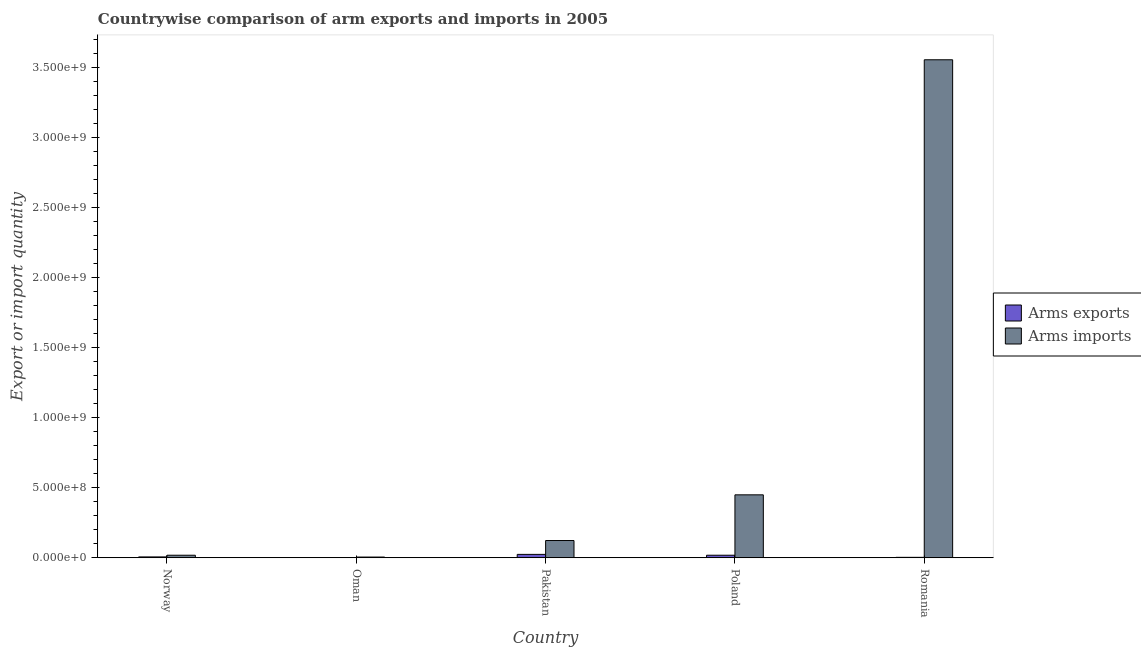How many bars are there on the 2nd tick from the left?
Your answer should be compact. 2. How many bars are there on the 2nd tick from the right?
Keep it short and to the point. 2. In how many cases, is the number of bars for a given country not equal to the number of legend labels?
Provide a succinct answer. 0. What is the arms imports in Romania?
Ensure brevity in your answer.  3.55e+09. Across all countries, what is the maximum arms imports?
Your response must be concise. 3.55e+09. Across all countries, what is the minimum arms imports?
Your answer should be very brief. 5.00e+06. In which country was the arms imports maximum?
Provide a succinct answer. Romania. In which country was the arms exports minimum?
Ensure brevity in your answer.  Oman. What is the total arms imports in the graph?
Keep it short and to the point. 4.15e+09. What is the difference between the arms exports in Pakistan and that in Romania?
Provide a succinct answer. 2.10e+07. What is the difference between the arms imports in Norway and the arms exports in Pakistan?
Offer a terse response. -6.00e+06. What is the average arms imports per country?
Give a very brief answer. 8.30e+08. What is the difference between the arms exports and arms imports in Oman?
Offer a terse response. -4.00e+06. In how many countries, is the arms imports greater than 2600000000 ?
Give a very brief answer. 1. What is the ratio of the arms exports in Pakistan to that in Poland?
Provide a short and direct response. 1.33. Is the arms exports in Oman less than that in Pakistan?
Provide a succinct answer. Yes. What is the difference between the highest and the lowest arms imports?
Give a very brief answer. 3.55e+09. What does the 2nd bar from the left in Pakistan represents?
Provide a succinct answer. Arms imports. What does the 2nd bar from the right in Pakistan represents?
Provide a succinct answer. Arms exports. How many countries are there in the graph?
Your answer should be very brief. 5. What is the difference between two consecutive major ticks on the Y-axis?
Offer a terse response. 5.00e+08. Does the graph contain grids?
Ensure brevity in your answer.  No. Where does the legend appear in the graph?
Keep it short and to the point. Center right. How many legend labels are there?
Provide a succinct answer. 2. How are the legend labels stacked?
Give a very brief answer. Vertical. What is the title of the graph?
Your answer should be compact. Countrywise comparison of arm exports and imports in 2005. Does "Commercial service imports" appear as one of the legend labels in the graph?
Ensure brevity in your answer.  No. What is the label or title of the X-axis?
Make the answer very short. Country. What is the label or title of the Y-axis?
Your answer should be very brief. Export or import quantity. What is the Export or import quantity in Arms exports in Norway?
Provide a short and direct response. 6.00e+06. What is the Export or import quantity in Arms imports in Norway?
Provide a succinct answer. 1.80e+07. What is the Export or import quantity in Arms exports in Pakistan?
Offer a very short reply. 2.40e+07. What is the Export or import quantity of Arms imports in Pakistan?
Ensure brevity in your answer.  1.23e+08. What is the Export or import quantity of Arms exports in Poland?
Offer a very short reply. 1.80e+07. What is the Export or import quantity of Arms imports in Poland?
Your response must be concise. 4.49e+08. What is the Export or import quantity in Arms imports in Romania?
Provide a succinct answer. 3.55e+09. Across all countries, what is the maximum Export or import quantity of Arms exports?
Ensure brevity in your answer.  2.40e+07. Across all countries, what is the maximum Export or import quantity of Arms imports?
Your answer should be compact. 3.55e+09. Across all countries, what is the minimum Export or import quantity of Arms imports?
Provide a short and direct response. 5.00e+06. What is the total Export or import quantity of Arms exports in the graph?
Provide a short and direct response. 5.20e+07. What is the total Export or import quantity in Arms imports in the graph?
Ensure brevity in your answer.  4.15e+09. What is the difference between the Export or import quantity of Arms imports in Norway and that in Oman?
Make the answer very short. 1.30e+07. What is the difference between the Export or import quantity of Arms exports in Norway and that in Pakistan?
Make the answer very short. -1.80e+07. What is the difference between the Export or import quantity of Arms imports in Norway and that in Pakistan?
Provide a short and direct response. -1.05e+08. What is the difference between the Export or import quantity in Arms exports in Norway and that in Poland?
Offer a terse response. -1.20e+07. What is the difference between the Export or import quantity in Arms imports in Norway and that in Poland?
Keep it short and to the point. -4.31e+08. What is the difference between the Export or import quantity in Arms exports in Norway and that in Romania?
Keep it short and to the point. 3.00e+06. What is the difference between the Export or import quantity of Arms imports in Norway and that in Romania?
Offer a terse response. -3.54e+09. What is the difference between the Export or import quantity of Arms exports in Oman and that in Pakistan?
Offer a very short reply. -2.30e+07. What is the difference between the Export or import quantity in Arms imports in Oman and that in Pakistan?
Ensure brevity in your answer.  -1.18e+08. What is the difference between the Export or import quantity in Arms exports in Oman and that in Poland?
Offer a very short reply. -1.70e+07. What is the difference between the Export or import quantity of Arms imports in Oman and that in Poland?
Your response must be concise. -4.44e+08. What is the difference between the Export or import quantity in Arms imports in Oman and that in Romania?
Offer a terse response. -3.55e+09. What is the difference between the Export or import quantity of Arms exports in Pakistan and that in Poland?
Provide a succinct answer. 6.00e+06. What is the difference between the Export or import quantity of Arms imports in Pakistan and that in Poland?
Provide a short and direct response. -3.26e+08. What is the difference between the Export or import quantity of Arms exports in Pakistan and that in Romania?
Provide a succinct answer. 2.10e+07. What is the difference between the Export or import quantity of Arms imports in Pakistan and that in Romania?
Ensure brevity in your answer.  -3.43e+09. What is the difference between the Export or import quantity of Arms exports in Poland and that in Romania?
Offer a very short reply. 1.50e+07. What is the difference between the Export or import quantity in Arms imports in Poland and that in Romania?
Provide a short and direct response. -3.10e+09. What is the difference between the Export or import quantity in Arms exports in Norway and the Export or import quantity in Arms imports in Pakistan?
Provide a succinct answer. -1.17e+08. What is the difference between the Export or import quantity in Arms exports in Norway and the Export or import quantity in Arms imports in Poland?
Your answer should be very brief. -4.43e+08. What is the difference between the Export or import quantity of Arms exports in Norway and the Export or import quantity of Arms imports in Romania?
Make the answer very short. -3.55e+09. What is the difference between the Export or import quantity of Arms exports in Oman and the Export or import quantity of Arms imports in Pakistan?
Your response must be concise. -1.22e+08. What is the difference between the Export or import quantity in Arms exports in Oman and the Export or import quantity in Arms imports in Poland?
Offer a terse response. -4.48e+08. What is the difference between the Export or import quantity in Arms exports in Oman and the Export or import quantity in Arms imports in Romania?
Provide a succinct answer. -3.55e+09. What is the difference between the Export or import quantity of Arms exports in Pakistan and the Export or import quantity of Arms imports in Poland?
Provide a succinct answer. -4.25e+08. What is the difference between the Export or import quantity in Arms exports in Pakistan and the Export or import quantity in Arms imports in Romania?
Make the answer very short. -3.53e+09. What is the difference between the Export or import quantity of Arms exports in Poland and the Export or import quantity of Arms imports in Romania?
Make the answer very short. -3.54e+09. What is the average Export or import quantity of Arms exports per country?
Provide a short and direct response. 1.04e+07. What is the average Export or import quantity in Arms imports per country?
Provide a succinct answer. 8.30e+08. What is the difference between the Export or import quantity of Arms exports and Export or import quantity of Arms imports in Norway?
Your answer should be compact. -1.20e+07. What is the difference between the Export or import quantity in Arms exports and Export or import quantity in Arms imports in Oman?
Offer a very short reply. -4.00e+06. What is the difference between the Export or import quantity in Arms exports and Export or import quantity in Arms imports in Pakistan?
Keep it short and to the point. -9.90e+07. What is the difference between the Export or import quantity in Arms exports and Export or import quantity in Arms imports in Poland?
Give a very brief answer. -4.31e+08. What is the difference between the Export or import quantity of Arms exports and Export or import quantity of Arms imports in Romania?
Provide a succinct answer. -3.55e+09. What is the ratio of the Export or import quantity in Arms exports in Norway to that in Oman?
Ensure brevity in your answer.  6. What is the ratio of the Export or import quantity of Arms imports in Norway to that in Oman?
Keep it short and to the point. 3.6. What is the ratio of the Export or import quantity in Arms imports in Norway to that in Pakistan?
Provide a short and direct response. 0.15. What is the ratio of the Export or import quantity of Arms imports in Norway to that in Poland?
Your answer should be compact. 0.04. What is the ratio of the Export or import quantity of Arms exports in Norway to that in Romania?
Offer a very short reply. 2. What is the ratio of the Export or import quantity of Arms imports in Norway to that in Romania?
Make the answer very short. 0.01. What is the ratio of the Export or import quantity in Arms exports in Oman to that in Pakistan?
Ensure brevity in your answer.  0.04. What is the ratio of the Export or import quantity in Arms imports in Oman to that in Pakistan?
Your response must be concise. 0.04. What is the ratio of the Export or import quantity of Arms exports in Oman to that in Poland?
Your response must be concise. 0.06. What is the ratio of the Export or import quantity in Arms imports in Oman to that in Poland?
Your answer should be compact. 0.01. What is the ratio of the Export or import quantity of Arms imports in Oman to that in Romania?
Provide a short and direct response. 0. What is the ratio of the Export or import quantity in Arms imports in Pakistan to that in Poland?
Your answer should be compact. 0.27. What is the ratio of the Export or import quantity of Arms imports in Pakistan to that in Romania?
Make the answer very short. 0.03. What is the ratio of the Export or import quantity of Arms exports in Poland to that in Romania?
Give a very brief answer. 6. What is the ratio of the Export or import quantity in Arms imports in Poland to that in Romania?
Your answer should be very brief. 0.13. What is the difference between the highest and the second highest Export or import quantity in Arms imports?
Your answer should be very brief. 3.10e+09. What is the difference between the highest and the lowest Export or import quantity of Arms exports?
Provide a succinct answer. 2.30e+07. What is the difference between the highest and the lowest Export or import quantity in Arms imports?
Provide a short and direct response. 3.55e+09. 